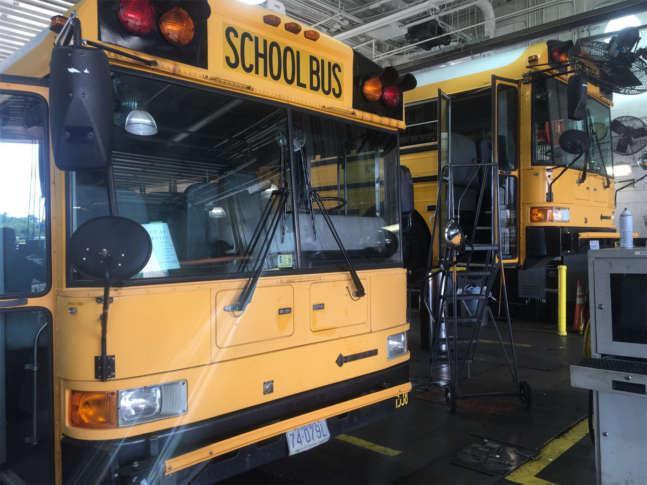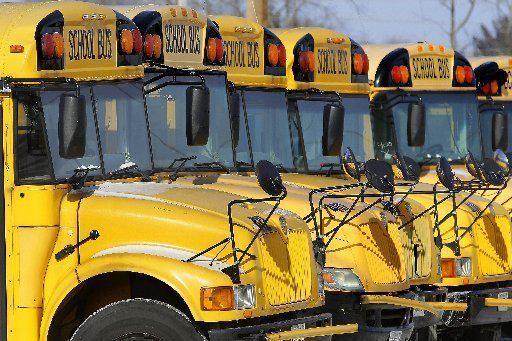The first image is the image on the left, the second image is the image on the right. Analyze the images presented: Is the assertion "One image shows schoolbuses parked next to each other facing rightward." valid? Answer yes or no. Yes. The first image is the image on the left, the second image is the image on the right. Analyze the images presented: Is the assertion "In the left image, one person is in front of the open side-entry passenger door of a bus." valid? Answer yes or no. No. 